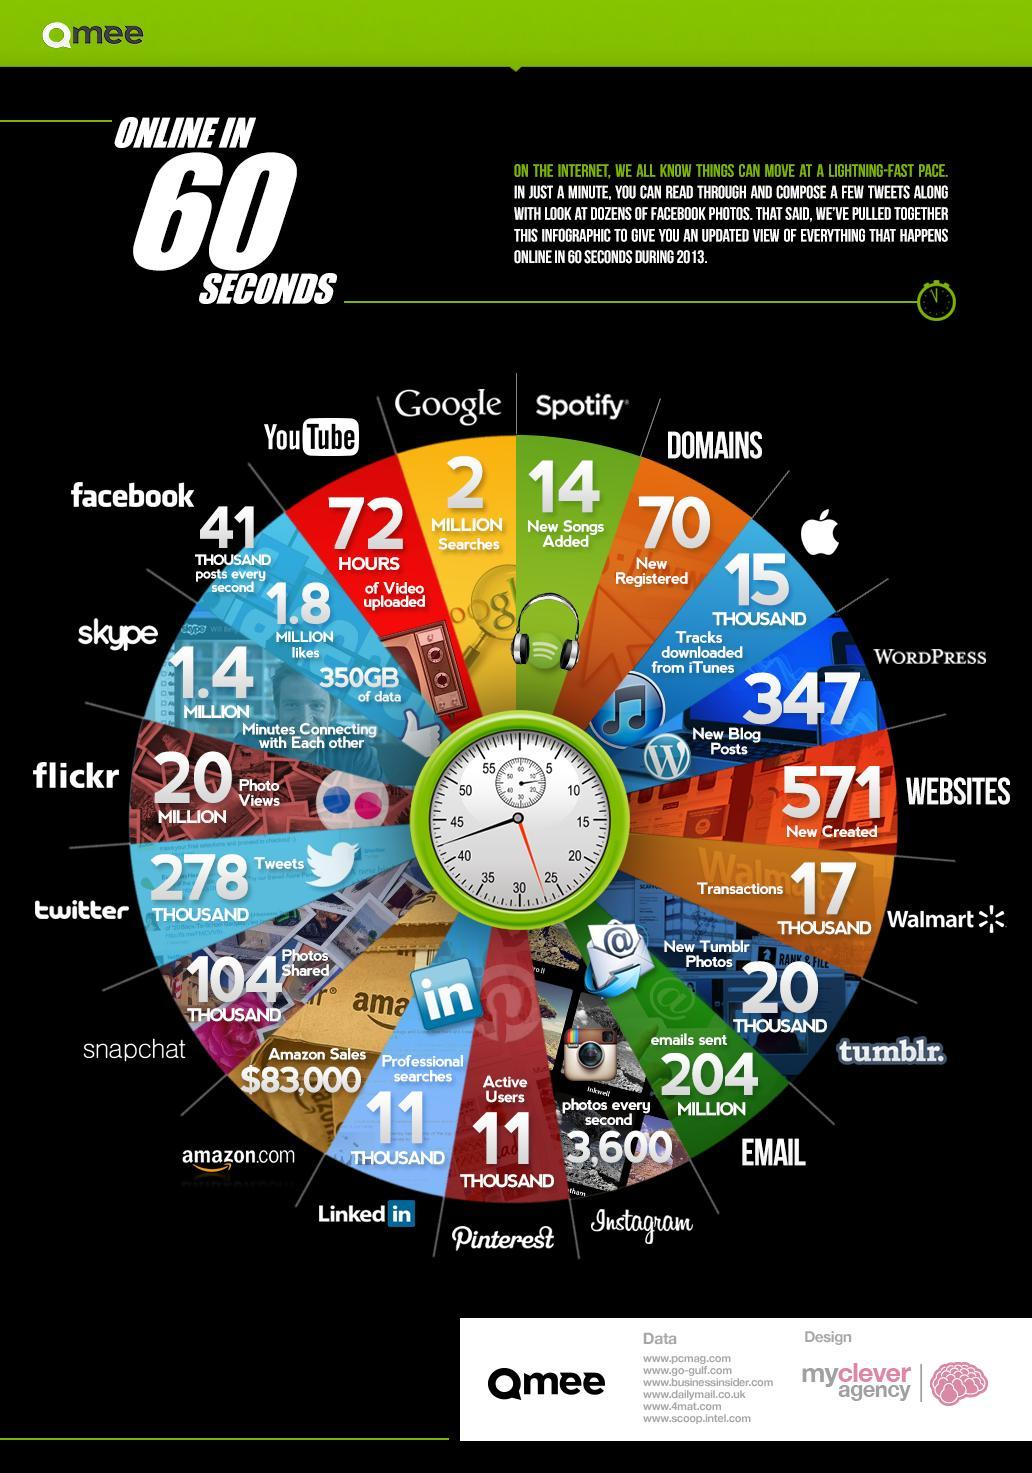How many photo views were done in flickr in 60 seconds of online during 2013?
Answer the question with a short phrase. 20 MILLION How many domains were newly registered online in 60 seconds during 2013? 70 How many google searches were done online in 60 seconds during 2013? 2 MILLION How many new songs were added in Spotify in 60 seconds of online during 2013? 14 How many websites were newly registered online in 60 seconds during 2013? 571 How many professional searches were made in Linkedin in 60 seconds of being online during 2013? 11 THOUSAND What is the amount of online amazon sales made in 60 seconds during 2013? $83,000 How many emails were sent online in 60 seconds during 2013? 204 MILLION 